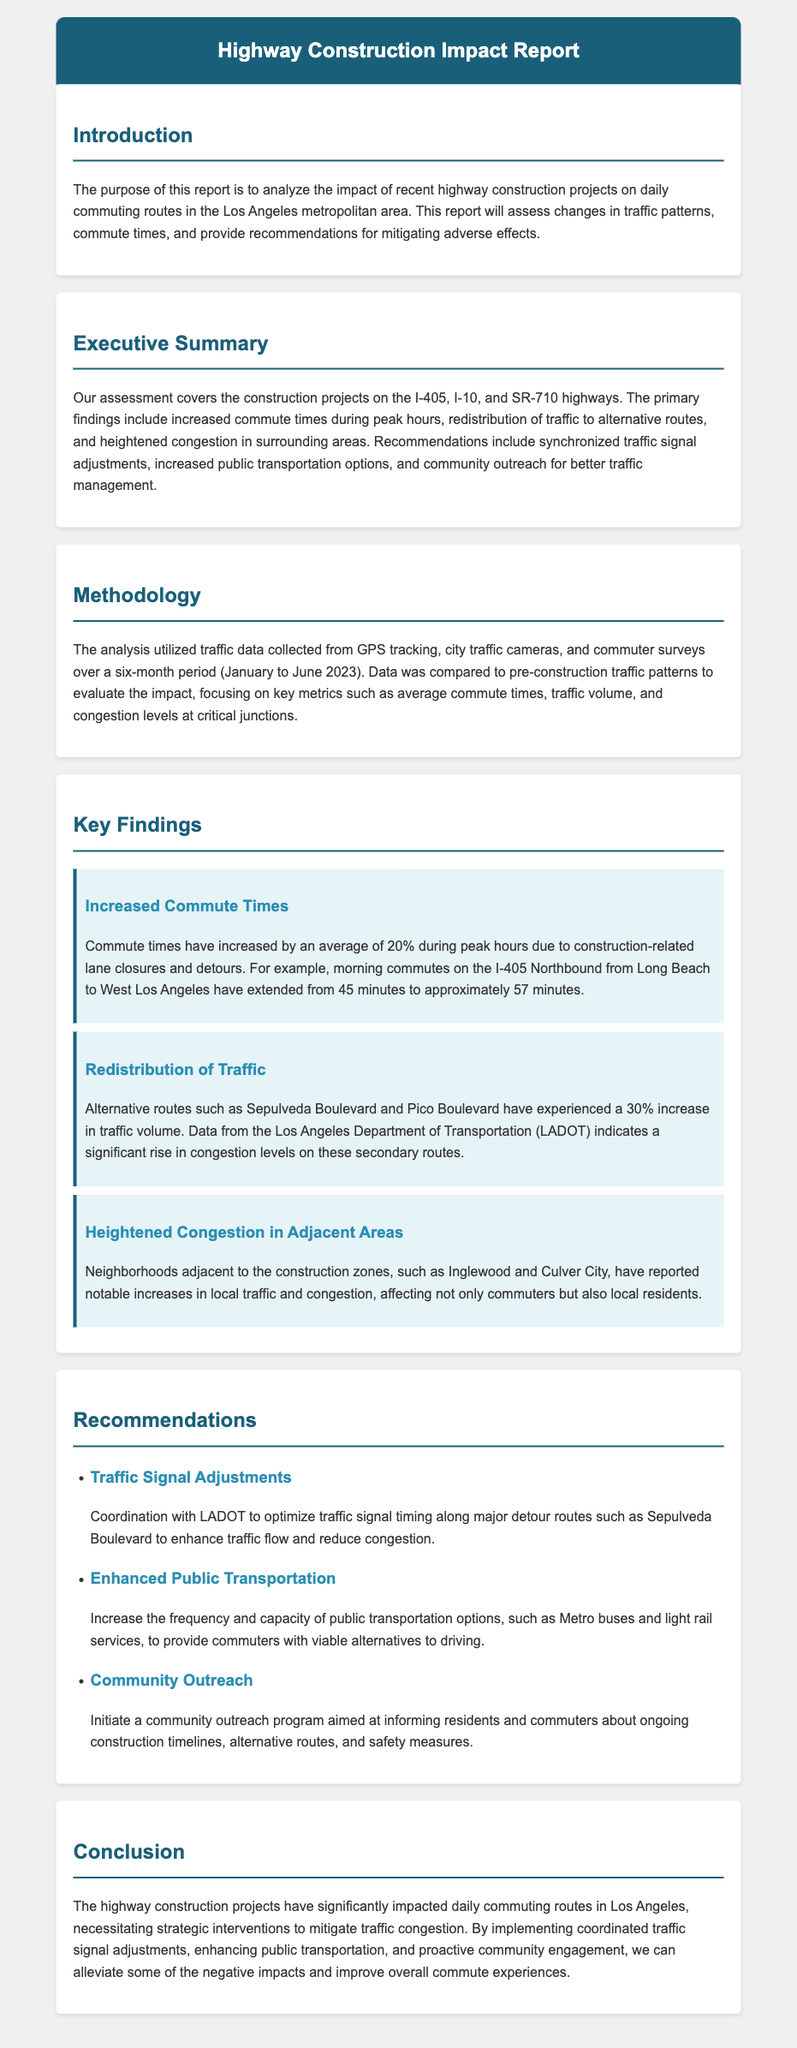What is the focus of this report? The report analyzes the impact of highway construction projects on daily commuting routes in Los Angeles.
Answer: highway construction projects What percentage did commute times increase during peak hours? The report states that commute times have increased by an average of 20% during peak hours.
Answer: 20% Which highways were assessed in the report? The report covers the construction projects on the I-405, I-10, and SR-710 highways.
Answer: I-405, I-10, SR-710 What alternative routes experienced an increase in traffic volume? According to the report, Sepulveda Boulevard and Pico Boulevard experienced a 30% increase in traffic volume.
Answer: Sepulveda Boulevard and Pico Boulevard What is one recommendation for mitigating traffic congestion? The report recommends coordinated traffic signal timing along major detour routes to enhance traffic flow.
Answer: Traffic Signal Adjustments Which neighborhoods reported increases in local traffic? The neighborhoods mentioned are Inglewood and Culver City.
Answer: Inglewood and Culver City How long was the data collected for the analysis? The analysis utilized traffic data collected over a six-month period.
Answer: six months What is a key finding regarding local residents? Local residents have reported notable increases in traffic and congestion.
Answer: increased local traffic and congestion 